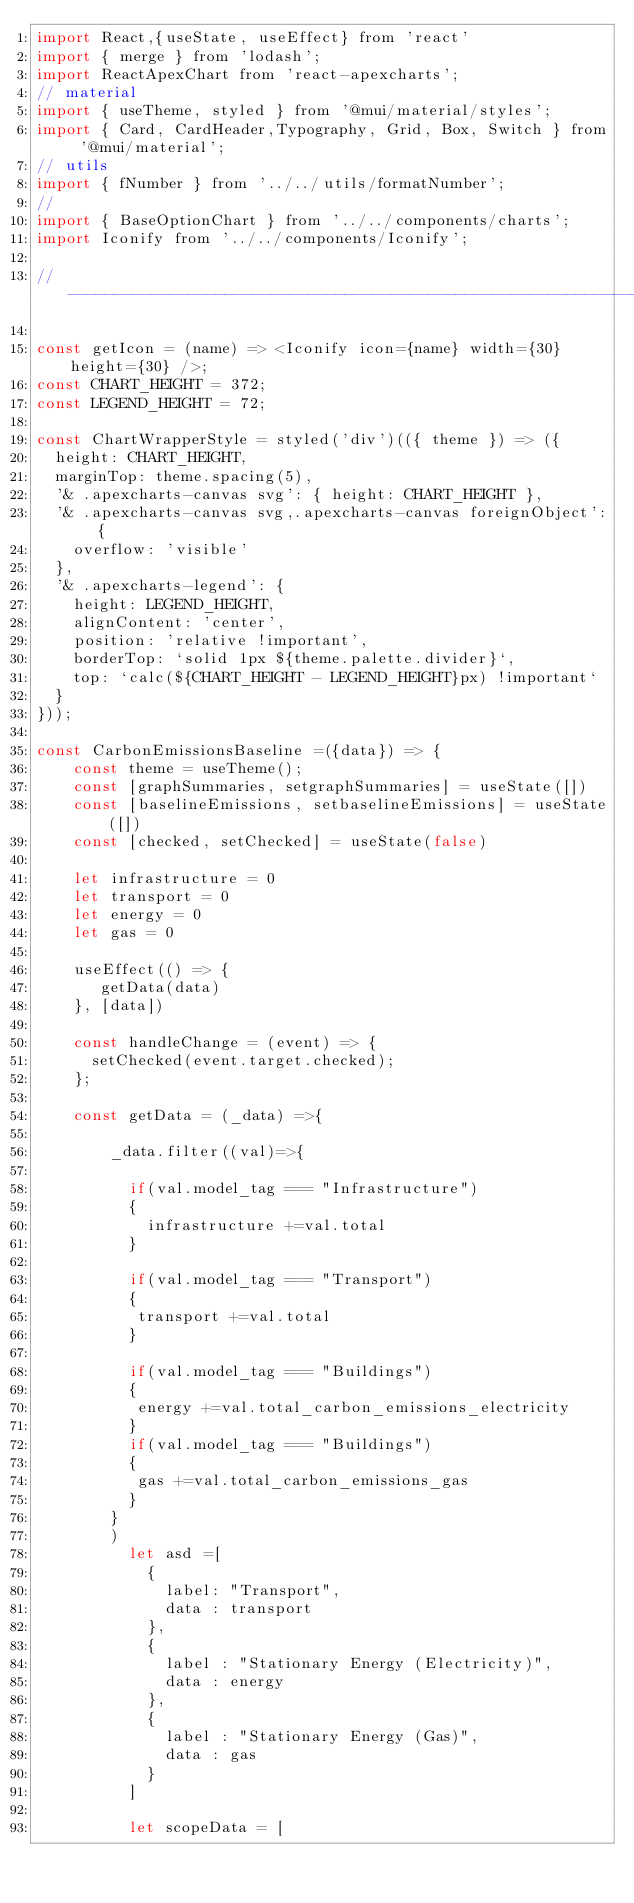Convert code to text. <code><loc_0><loc_0><loc_500><loc_500><_JavaScript_>import React,{useState, useEffect} from 'react'
import { merge } from 'lodash';
import ReactApexChart from 'react-apexcharts';
// material
import { useTheme, styled } from '@mui/material/styles';
import { Card, CardHeader,Typography, Grid, Box, Switch } from '@mui/material';
// utils
import { fNumber } from '../../utils/formatNumber';
//
import { BaseOptionChart } from '../../components/charts';
import Iconify from '../../components/Iconify';

// ----------------------------------------------------------------------

const getIcon = (name) => <Iconify icon={name} width={30} height={30} />;
const CHART_HEIGHT = 372;
const LEGEND_HEIGHT = 72;

const ChartWrapperStyle = styled('div')(({ theme }) => ({
  height: CHART_HEIGHT,
  marginTop: theme.spacing(5),
  '& .apexcharts-canvas svg': { height: CHART_HEIGHT },
  '& .apexcharts-canvas svg,.apexcharts-canvas foreignObject': {
    overflow: 'visible'
  },
  '& .apexcharts-legend': {
    height: LEGEND_HEIGHT,
    alignContent: 'center',
    position: 'relative !important',
    borderTop: `solid 1px ${theme.palette.divider}`,
    top: `calc(${CHART_HEIGHT - LEGEND_HEIGHT}px) !important`
  }
}));

const CarbonEmissionsBaseline =({data}) => {
    const theme = useTheme();
    const [graphSummaries, setgraphSummaries] = useState([])
    const [baselineEmissions, setbaselineEmissions] = useState([])
    const [checked, setChecked] = useState(false)

    let infrastructure = 0
    let transport = 0
    let energy = 0
    let gas = 0

    useEffect(() => {
       getData(data)
    }, [data])

    const handleChange = (event) => {
      setChecked(event.target.checked);
    };

    const getData = (_data) =>{     
     
        _data.filter((val)=>{
           
          if(val.model_tag === "Infrastructure")
          {
            infrastructure +=val.total
          }
      
          if(val.model_tag === "Transport")
          {
           transport +=val.total
          }
      
          if(val.model_tag === "Buildings")
          {
           energy +=val.total_carbon_emissions_electricity
          }
          if(val.model_tag === "Buildings")
          {
           gas +=val.total_carbon_emissions_gas
          }                
        }
        )
          let asd =[       
            {
              label: "Transport",
              data : transport
            },
            {
              label : "Stationary Energy (Electricity)",
              data : energy
            },
            {
              label : "Stationary Energy (Gas)",
              data : gas
            }
          ]
      
          let scopeData = [</code> 